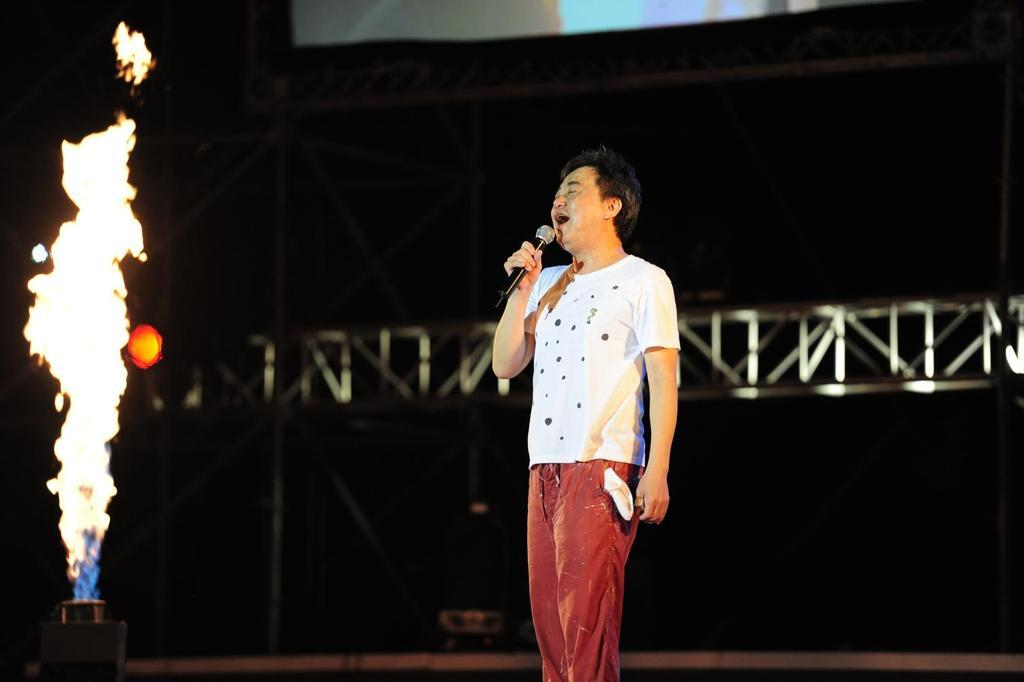What is the man on the stage doing? The man on the stage is singing into a microphone. Can you describe the man's activity in more detail? The man is singing, which suggests he might be performing for an audience. What is happening at the left side of the image? There is a fire at the left side of the image. What type of magic trick is the man performing with the stone in the image? There is no mention of a stone or a magic trick in the image. The man is singing into a microphone, and there is a fire at the left side of the image. 